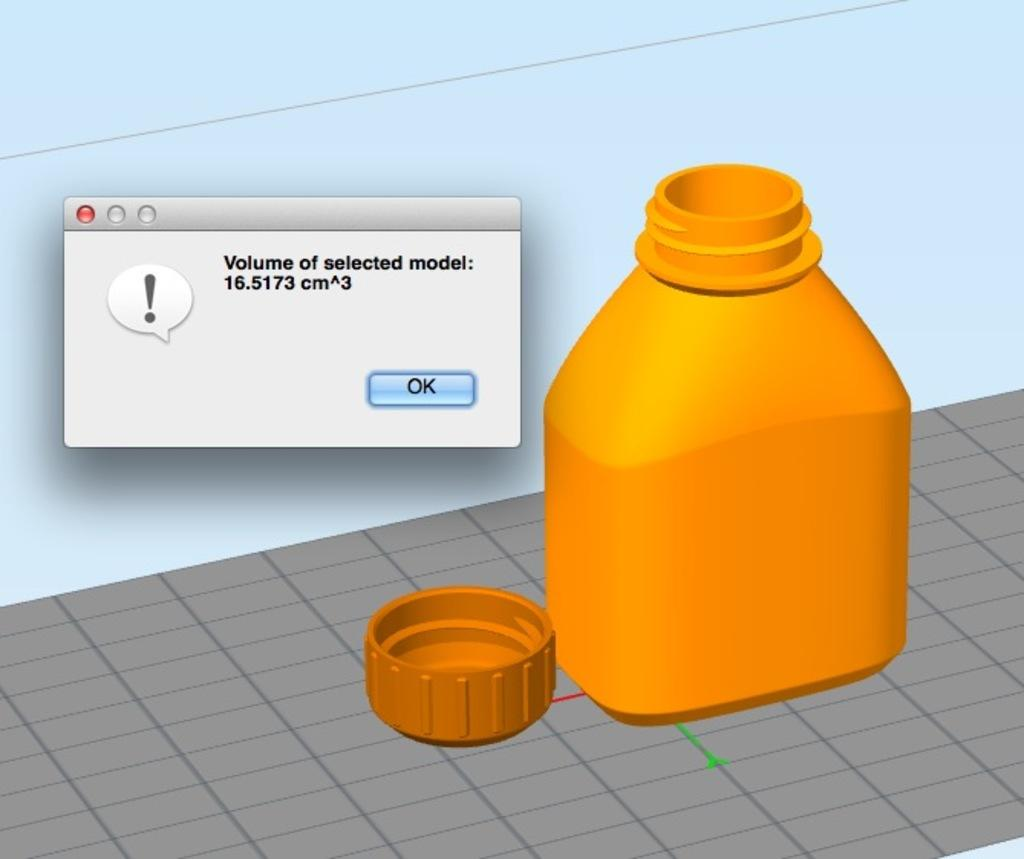<image>
Provide a brief description of the given image. A computer message that shows the volume of the selected model. 